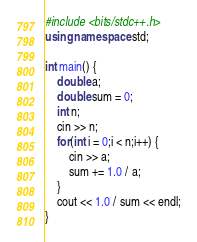Convert code to text. <code><loc_0><loc_0><loc_500><loc_500><_C++_>#include <bits/stdc++.h>
using namespace std;

int main() {
    double a;
    double sum = 0;
    int n;
    cin >> n;
    for(int i = 0;i < n;i++) {
        cin >> a;
        sum += 1.0 / a;
    }
    cout << 1.0 / sum << endl;
}
</code> 